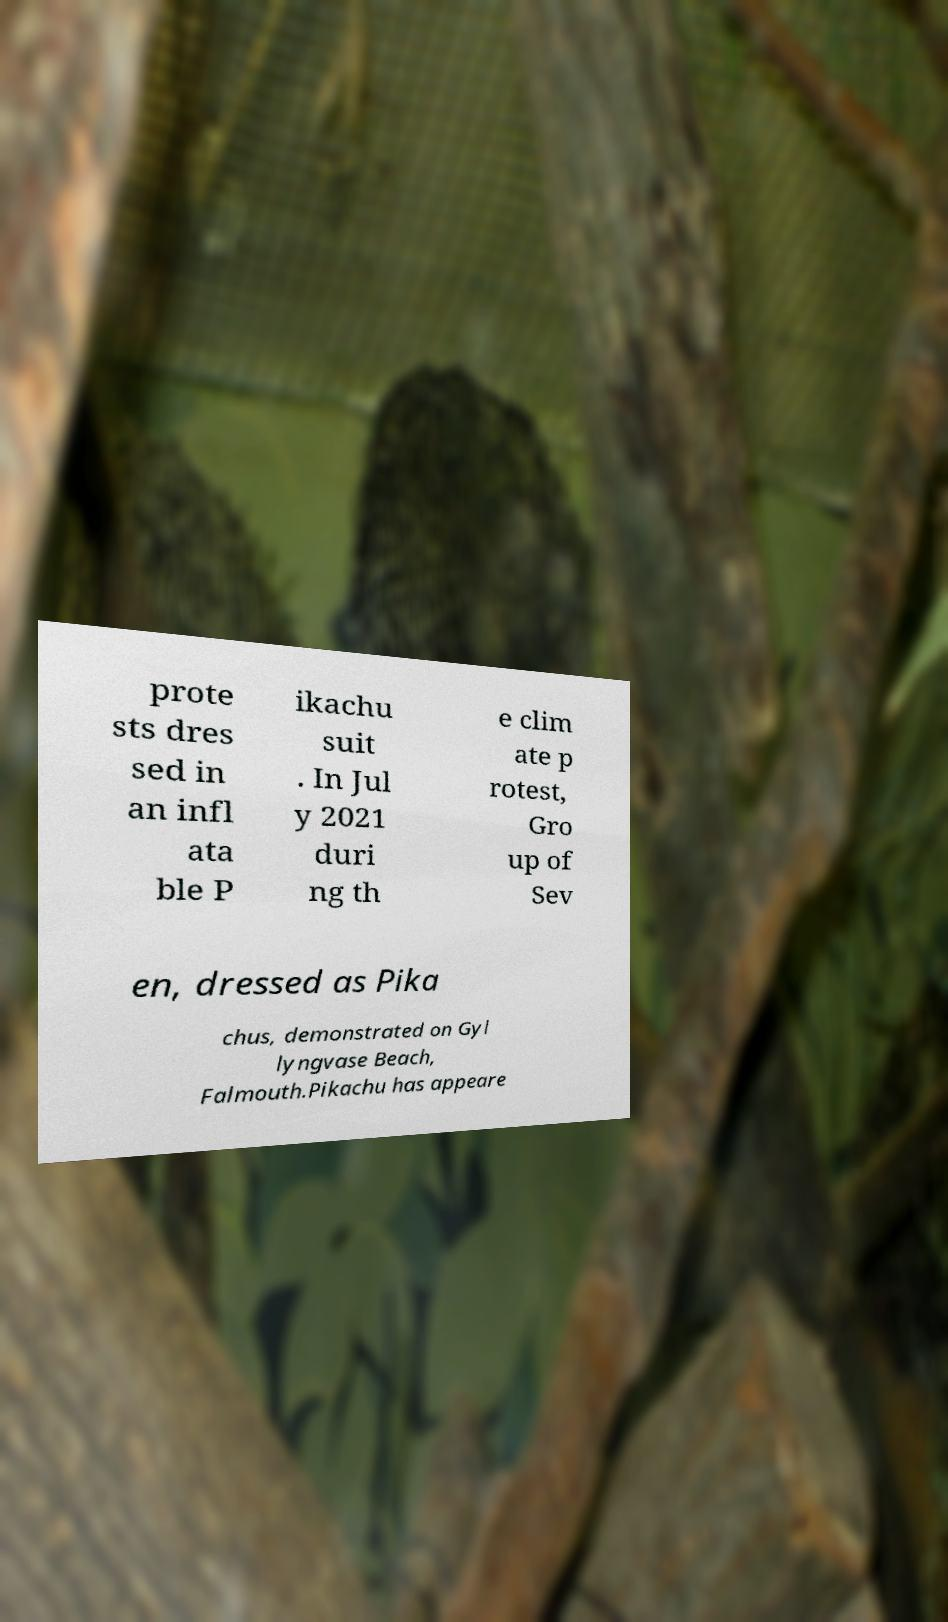Please identify and transcribe the text found in this image. prote sts dres sed in an infl ata ble P ikachu suit . In Jul y 2021 duri ng th e clim ate p rotest, Gro up of Sev en, dressed as Pika chus, demonstrated on Gyl lyngvase Beach, Falmouth.Pikachu has appeare 